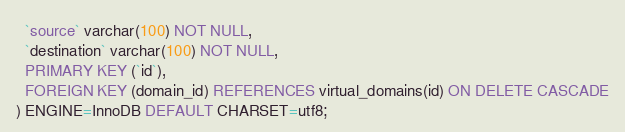Convert code to text. <code><loc_0><loc_0><loc_500><loc_500><_SQL_>  `source` varchar(100) NOT NULL,
  `destination` varchar(100) NOT NULL,
  PRIMARY KEY (`id`),
  FOREIGN KEY (domain_id) REFERENCES virtual_domains(id) ON DELETE CASCADE
) ENGINE=InnoDB DEFAULT CHARSET=utf8;
</code> 